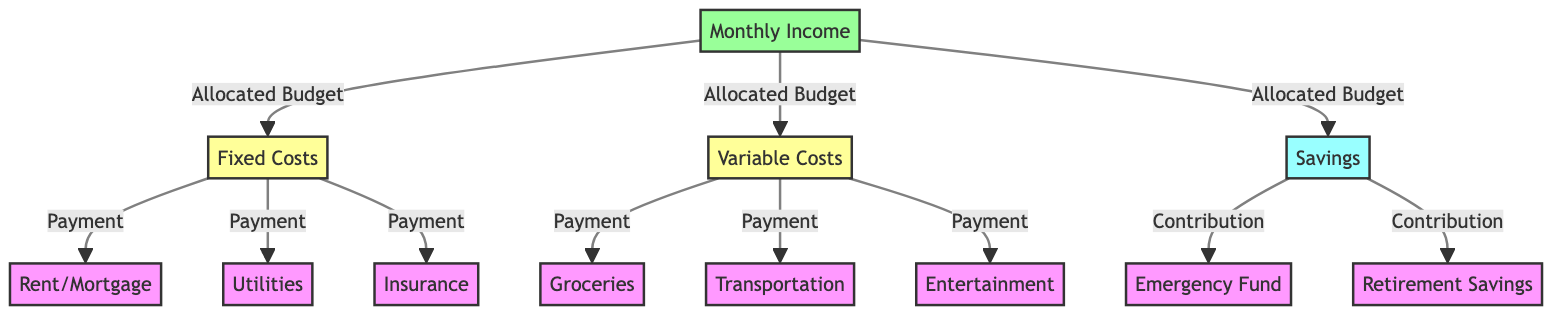What are the three main categories of expenses identified in the diagram? The three main categories are Fixed Costs, Variable Costs, and Savings as per the diagram. These categories represent how the monthly income is allocated among different expenses.
Answer: Fixed Costs, Variable Costs, Savings How many types of fixed costs are listed in the diagram? There are three types of fixed costs indicated: Rent/Mortgage, Utilities, and Insurance. This is clear from the connections leading from the Fixed Costs node.
Answer: 3 Which type of savings is aimed at retirement? The diagram specifies Retirement Savings as one type of savings, which is indicated as a direct flow from the Savings node.
Answer: Retirement Savings What type of costs include groceries and entertainment? The Variable Costs node includes Groceries and Entertainment, based on how these expenses are linked in the diagram.
Answer: Variable Costs Which expense is directly connected to emergency fund savings? The Emergency Fund is directly connected to the Savings node in the diagram, showing that it is part of the savings allocation.
Answer: Emergency Fund Between fixed costs and variable costs, which is responsible for the payment of utilities? Utilities are categorized under Fixed Costs as shown by the link from Fixed Costs to the Utilities node in the diagram.
Answer: Fixed Costs How many different components relate directly to the income in the diagram? Income is linked to three components: Fixed Costs, Variable Costs, and Savings, as outlined in the flow from the Income node.
Answer: 3 Which expense category includes transportation costs? Transportation falls under Variable Costs, evident from the diagram showing a connection from Variable Costs to the Transportation node.
Answer: Variable Costs What is the relationship between income and savings? The relationship is shown through an allocation where Income directly contributes to the Savings node, indicating a portion of the income is saved.
Answer: Allocation 